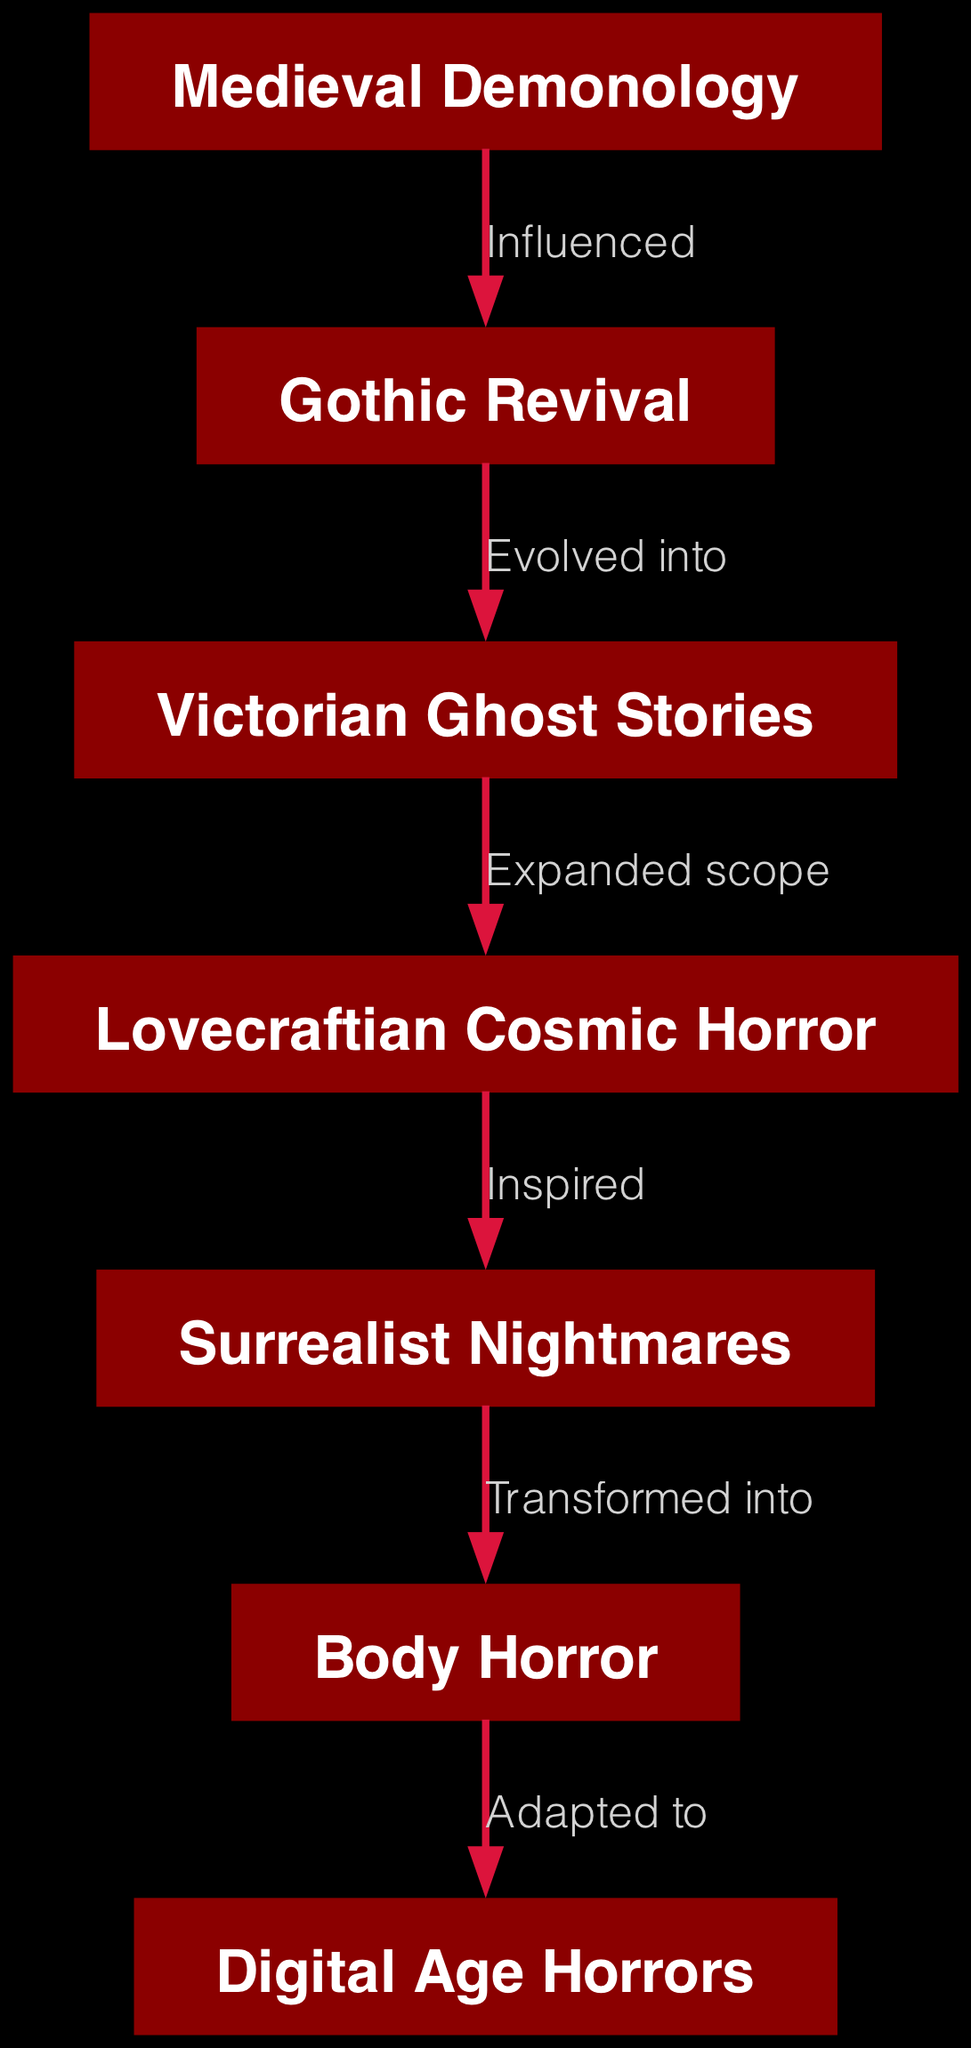What is the first node in the graph? The first node, based on the visual layout, is "Medieval Demonology," which appears at the top of the directed graph.
Answer: Medieval Demonology How many nodes are present in the diagram? Counting the nodes listed, there are a total of seven nodes in the directed graph.
Answer: 7 What label connects "Gothic Revival" and "Victorian Ghost Stories"? The relationship labeled between "Gothic Revival" and "Victorian Ghost Stories" is "Evolved into," indicating a progression from one theme to another.
Answer: Evolved into Which node expands the scope of "Victorian Ghost Stories"? The node that expands the scope of "Victorian Ghost Stories" is "Lovecraftian Cosmic Horror," which indicates a growth in thematic elements.
Answer: Lovecraftian Cosmic Horror What is the last node in the graph? The last node in the directed graph is "Digital Age Horrors," which is positioned at the bottom of the flow of connections.
Answer: Digital Age Horrors How does "Surrealist Nightmares" relate to "Body Horror"? The relationship between "Surrealist Nightmares" and "Body Horror" is labeled as "Transformed into," suggesting a change from one theme to another.
Answer: Transformed into What is the flow of influence from "Medieval Demonology" to "Digital Age Horrors"? The flow begins from "Medieval Demonology" to "Gothic Revival," then evolves into "Victorian Ghost Stories," which expands into "Lovecraftian Cosmic Horror," leading to "Surrealist Nightmares," transforming into "Body Horror," and finally adapting into "Digital Age Horrors." This shows a sequential evolution across multiple themes.
Answer: Medieval Demonology > Gothic Revival > Victorian Ghost Stories > Lovecraftian Cosmic Horror > Surrealist Nightmares > Body Horror > Digital Age Horrors Which theme is inspired by Lovecraftian elements? The theme inspired by Lovecraftian elements is "Surrealist Nightmares," indicating a direct influence evident in its characteristics.
Answer: Surrealist Nightmares How many edges are in the diagram? There are a total of six edges connecting the nodes in the directed graph, each representing a relationship or influence between the themes.
Answer: 6 